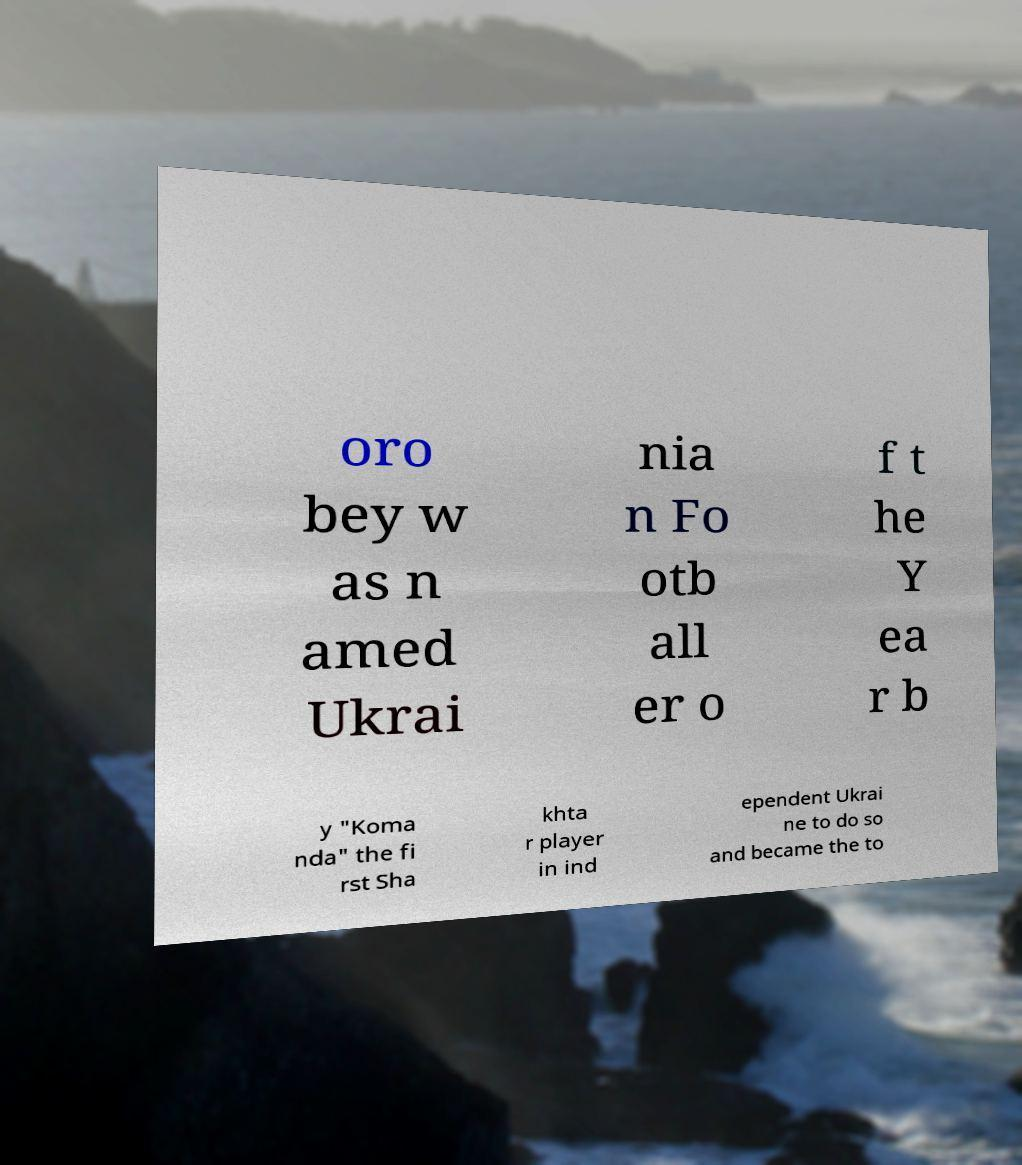Please identify and transcribe the text found in this image. oro bey w as n amed Ukrai nia n Fo otb all er o f t he Y ea r b y "Koma nda" the fi rst Sha khta r player in ind ependent Ukrai ne to do so and became the to 